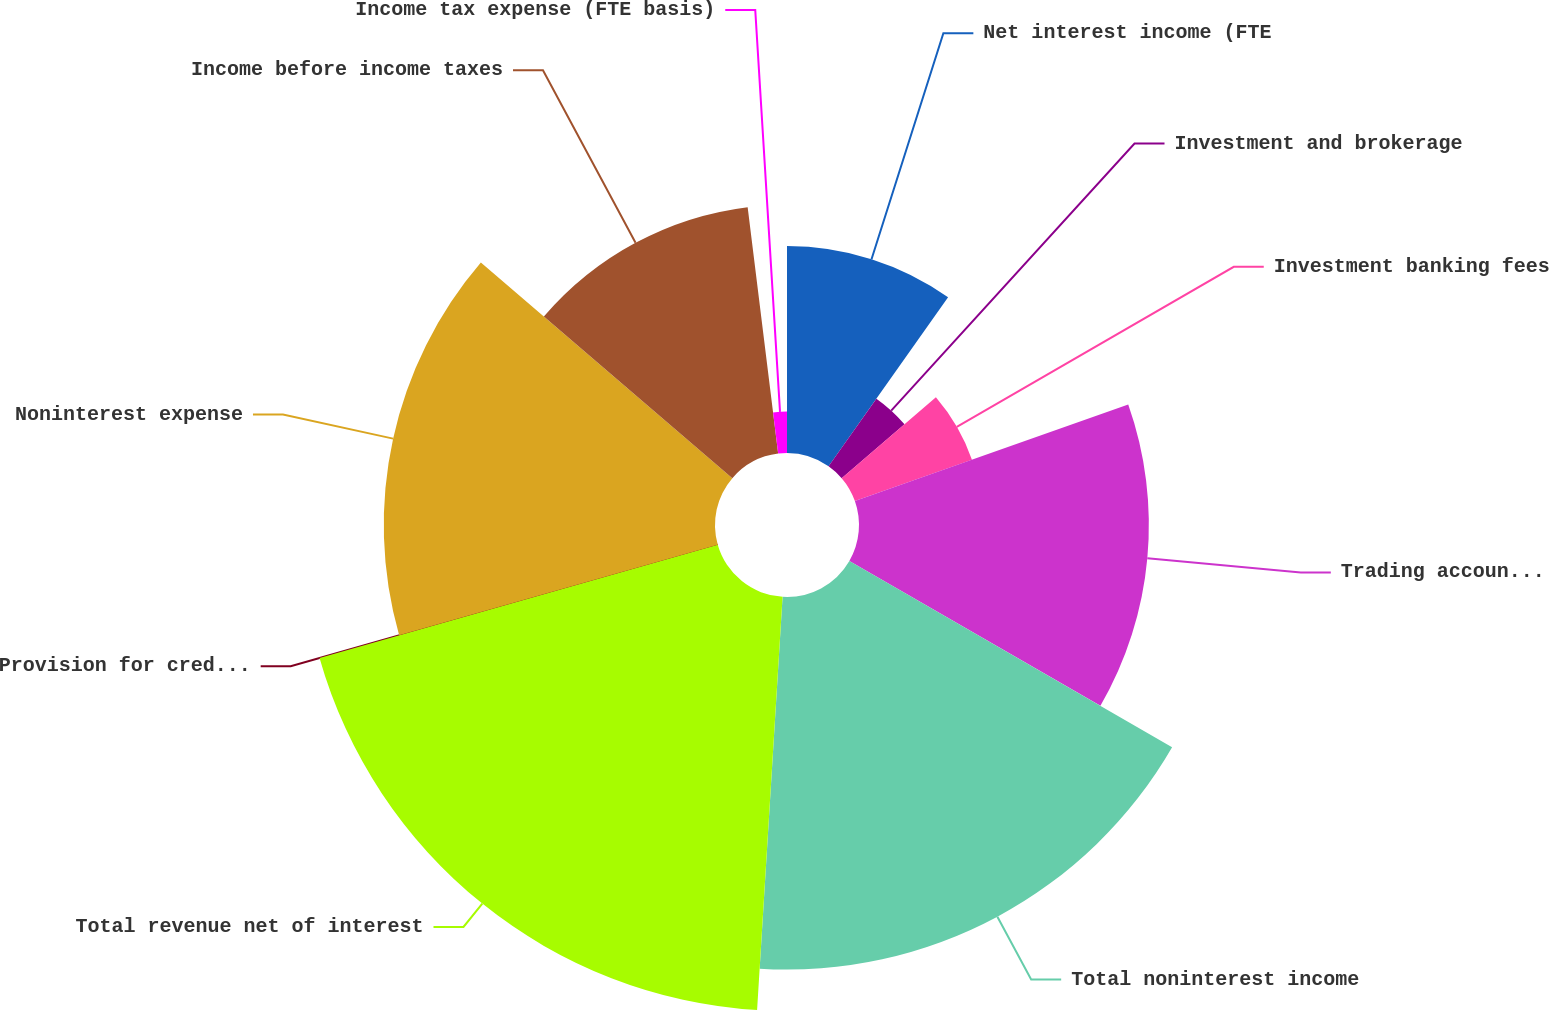Convert chart to OTSL. <chart><loc_0><loc_0><loc_500><loc_500><pie_chart><fcel>Net interest income (FTE<fcel>Investment and brokerage<fcel>Investment banking fees<fcel>Trading account profits<fcel>Total noninterest income<fcel>Total revenue net of interest<fcel>Provision for credit losses<fcel>Noninterest expense<fcel>Income before income taxes<fcel>Income tax expense (FTE basis)<nl><fcel>9.8%<fcel>3.92%<fcel>5.88%<fcel>13.73%<fcel>17.65%<fcel>19.61%<fcel>0.0%<fcel>15.69%<fcel>11.76%<fcel>1.96%<nl></chart> 